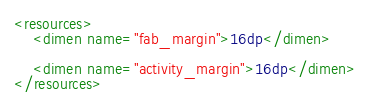<code> <loc_0><loc_0><loc_500><loc_500><_XML_><resources>
    <dimen name="fab_margin">16dp</dimen>

    <dimen name="activity_margin">16dp</dimen>
</resources>

</code> 